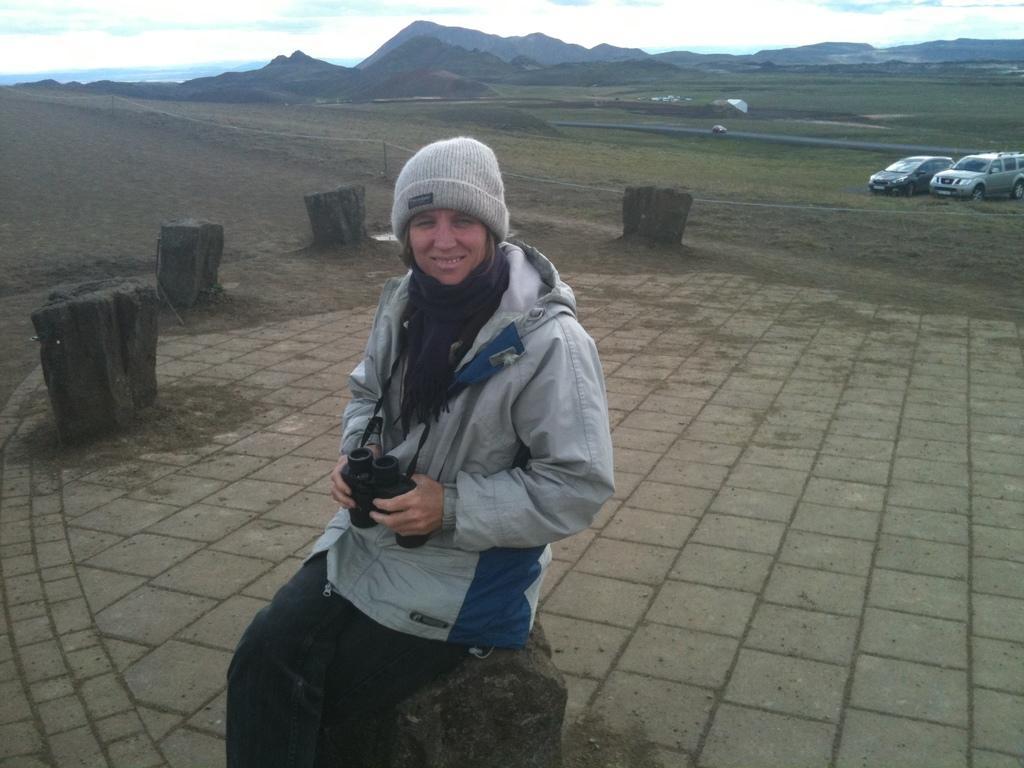Describe this image in one or two sentences. In this image there is the sky towards the top of the image, there are clouds in the sky, there are mountains, there is grass, there is a fencing, there are vehicles towards the right of the image, there is a woman sitting on the stone, she is wearing a cap. 